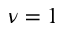Convert formula to latex. <formula><loc_0><loc_0><loc_500><loc_500>\nu = 1</formula> 